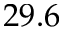<formula> <loc_0><loc_0><loc_500><loc_500>2 9 . 6</formula> 